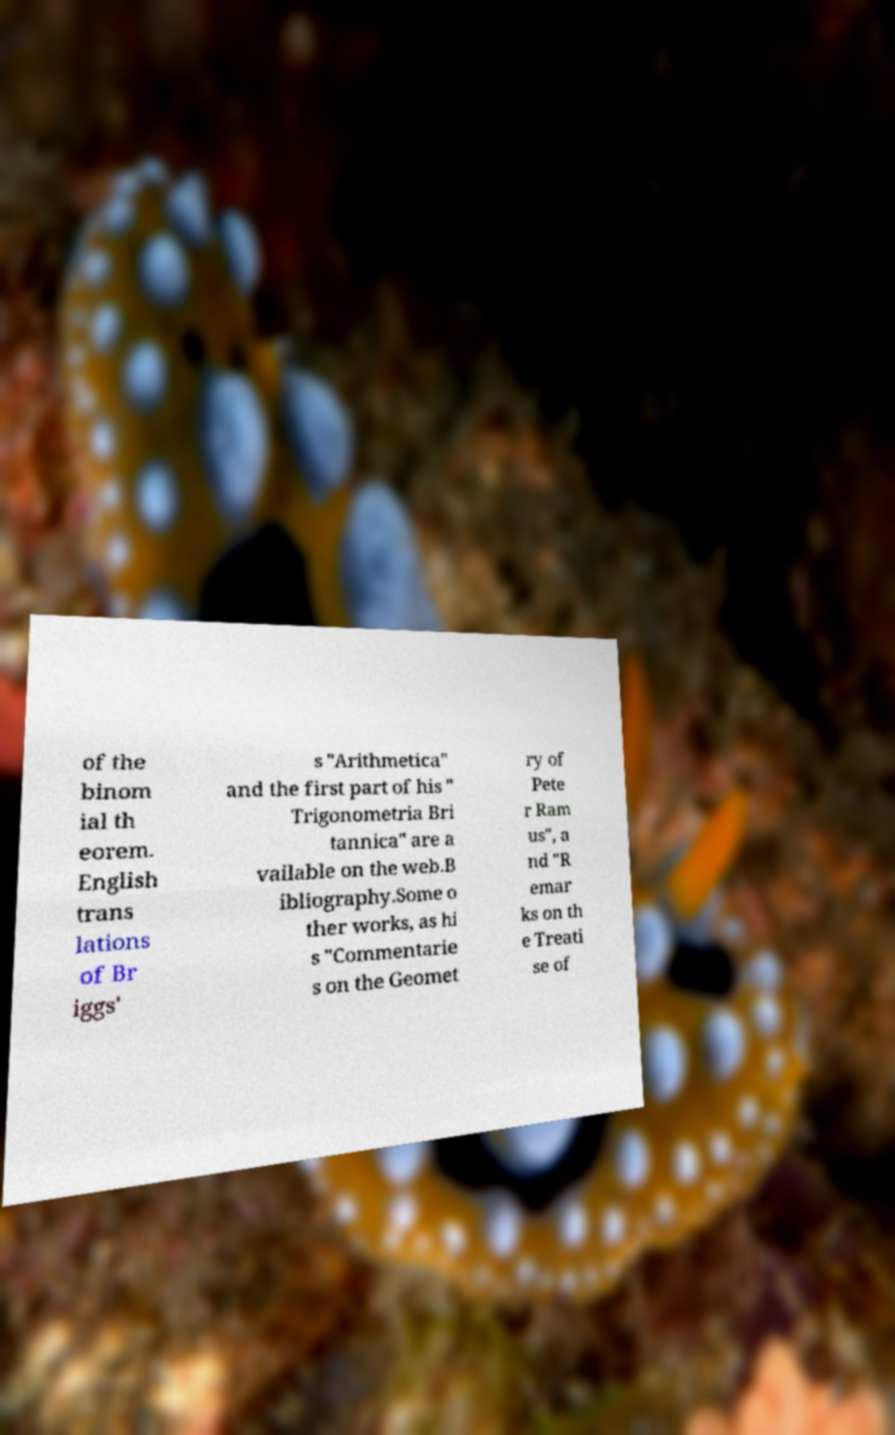Please read and relay the text visible in this image. What does it say? of the binom ial th eorem. English trans lations of Br iggs' s "Arithmetica" and the first part of his " Trigonometria Bri tannica" are a vailable on the web.B ibliography.Some o ther works, as hi s "Commentarie s on the Geomet ry of Pete r Ram us", a nd "R emar ks on th e Treati se of 